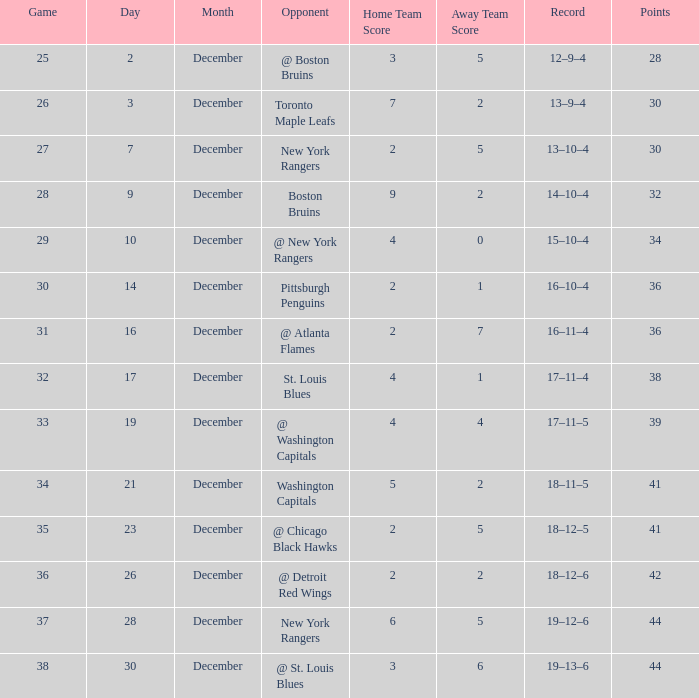Which Score has a Record of 18–11–5? 5–2. 